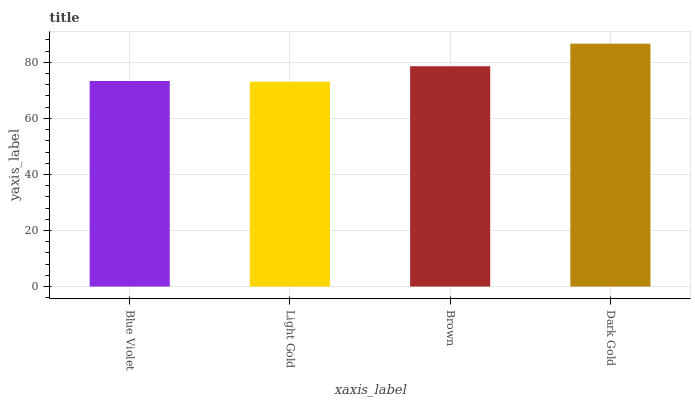Is Brown the minimum?
Answer yes or no. No. Is Brown the maximum?
Answer yes or no. No. Is Brown greater than Light Gold?
Answer yes or no. Yes. Is Light Gold less than Brown?
Answer yes or no. Yes. Is Light Gold greater than Brown?
Answer yes or no. No. Is Brown less than Light Gold?
Answer yes or no. No. Is Brown the high median?
Answer yes or no. Yes. Is Blue Violet the low median?
Answer yes or no. Yes. Is Blue Violet the high median?
Answer yes or no. No. Is Dark Gold the low median?
Answer yes or no. No. 